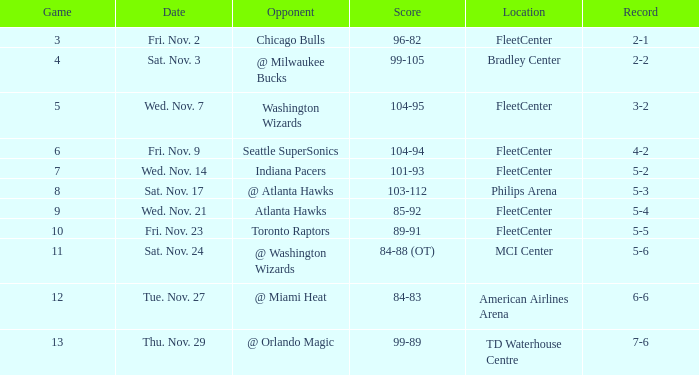On what date did Fleetcenter have a game lower than 9 with a score of 104-94? Fri. Nov. 9. 